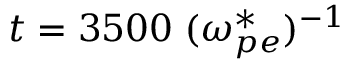<formula> <loc_0><loc_0><loc_500><loc_500>t = 3 5 0 0 \, ( \omega _ { p e } ^ { * } ) ^ { - 1 }</formula> 